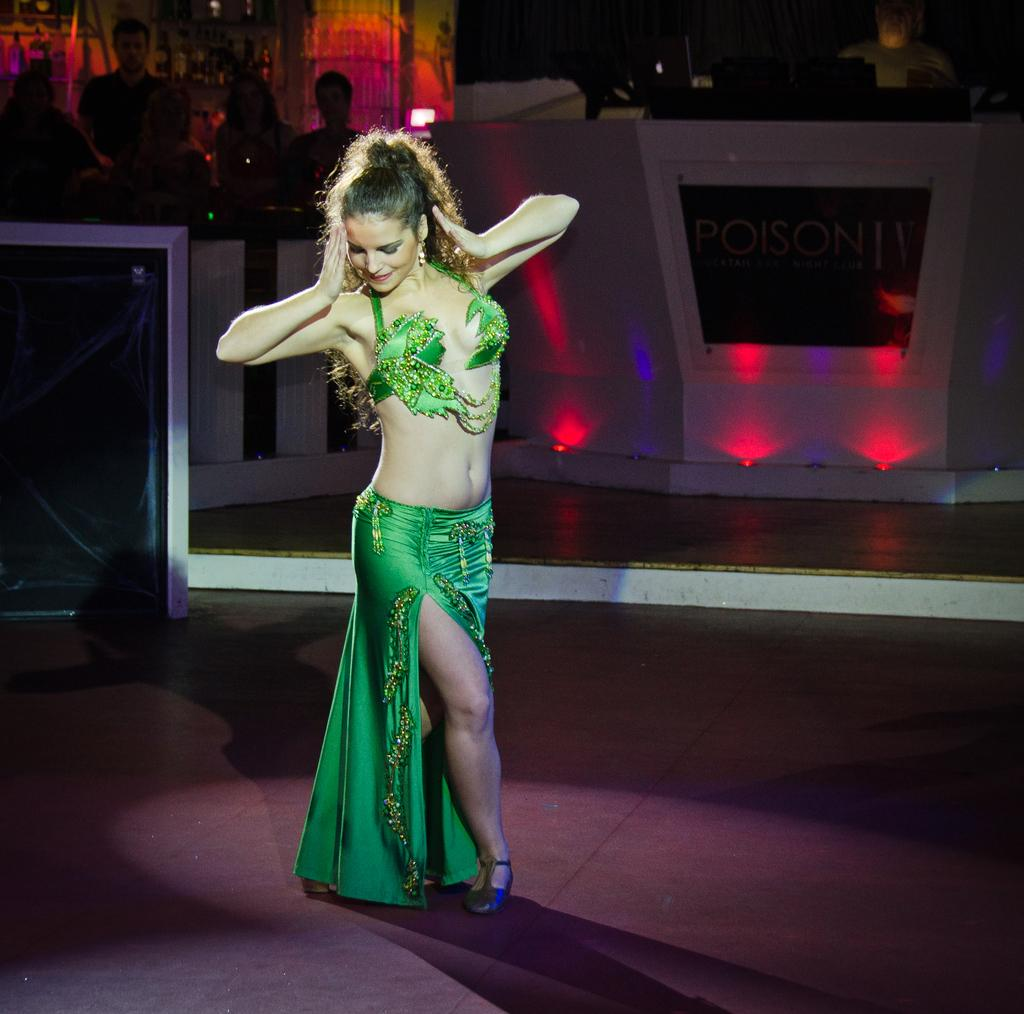What is the main subject of the image? There is a woman standing in the middle of the image. What is the woman doing in the image? The woman is smiling. Are there any other people in the image? Yes, there are people standing behind her. What are the people behind the woman doing? The people are watching the woman. What object can be seen in the image besides the people? There is a table in the image. What type of card is the woman holding in the image? There is no card present in the image; the woman is simply standing and smiling. 